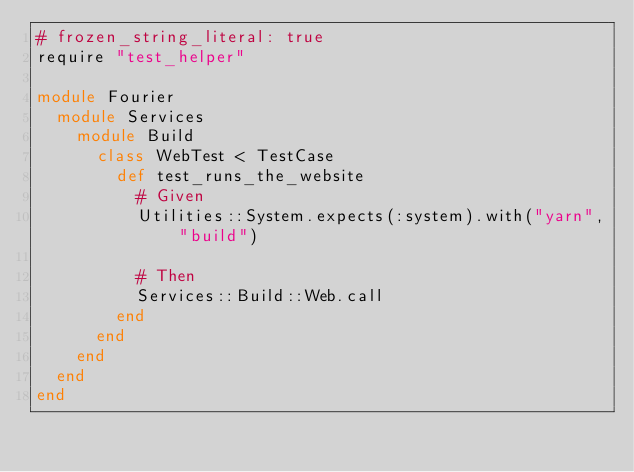Convert code to text. <code><loc_0><loc_0><loc_500><loc_500><_Ruby_># frozen_string_literal: true
require "test_helper"

module Fourier
  module Services
    module Build
      class WebTest < TestCase
        def test_runs_the_website
          # Given
          Utilities::System.expects(:system).with("yarn", "build")

          # Then
          Services::Build::Web.call
        end
      end
    end
  end
end
</code> 